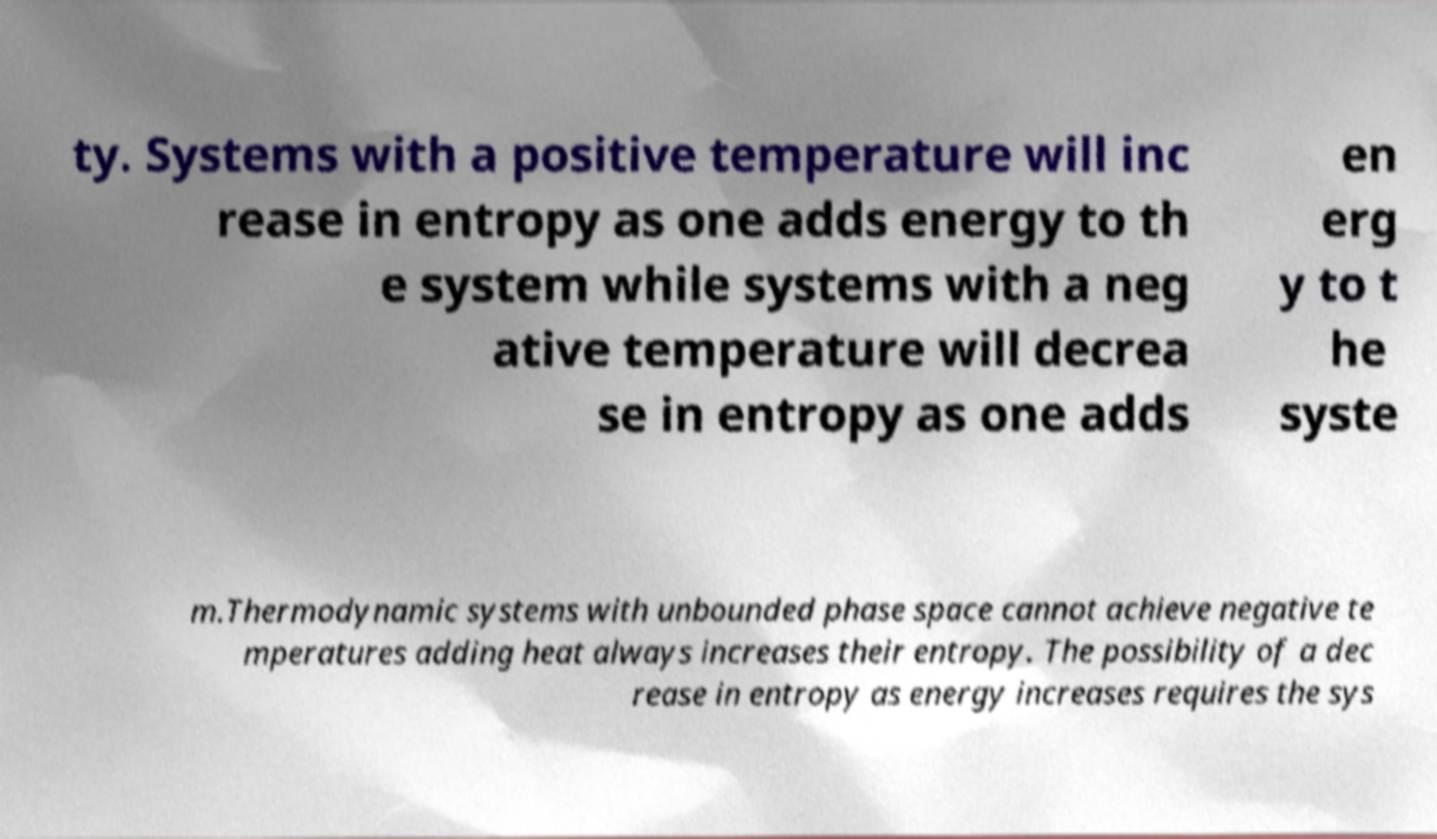For documentation purposes, I need the text within this image transcribed. Could you provide that? ty. Systems with a positive temperature will inc rease in entropy as one adds energy to th e system while systems with a neg ative temperature will decrea se in entropy as one adds en erg y to t he syste m.Thermodynamic systems with unbounded phase space cannot achieve negative te mperatures adding heat always increases their entropy. The possibility of a dec rease in entropy as energy increases requires the sys 